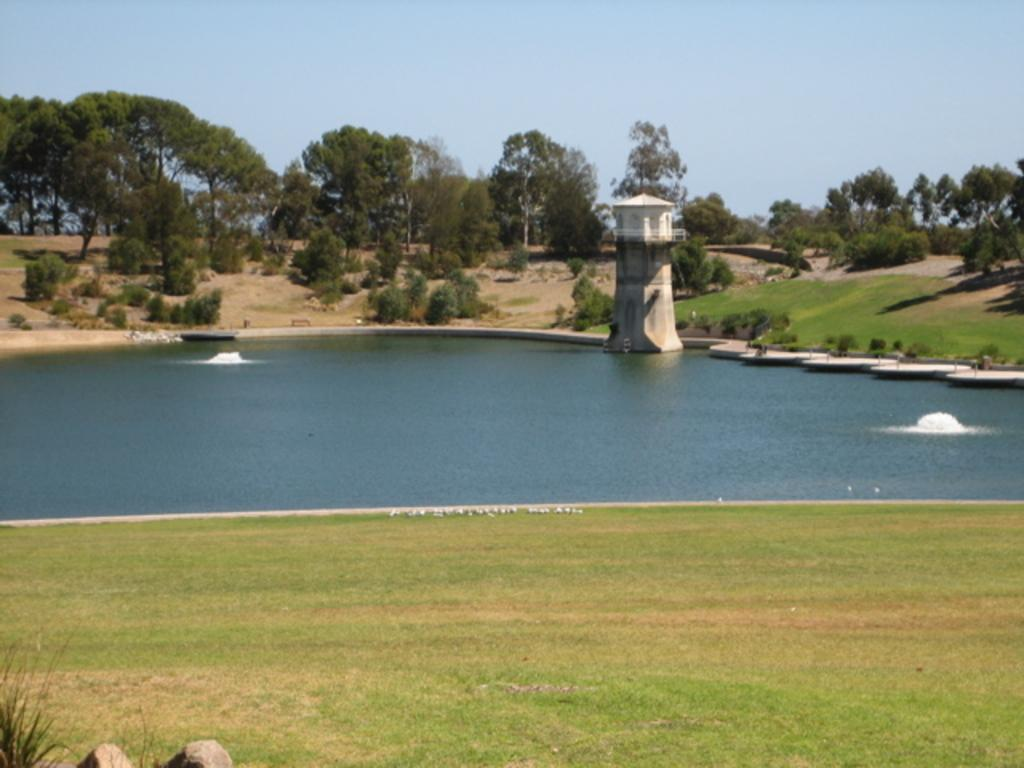What type of vegetation can be seen in the image? There are trees, plants, and grass visible in the image. What other objects can be seen in the image? There are stones and a tower in the water in the image. What is visible in the background of the image? The sky is visible in the background of the image. Can you see any mittens in the image? There are no mittens present in the image. Is there any steam coming from the tower in the water? There is no steam visible in the image; only the tower in the water is present. 